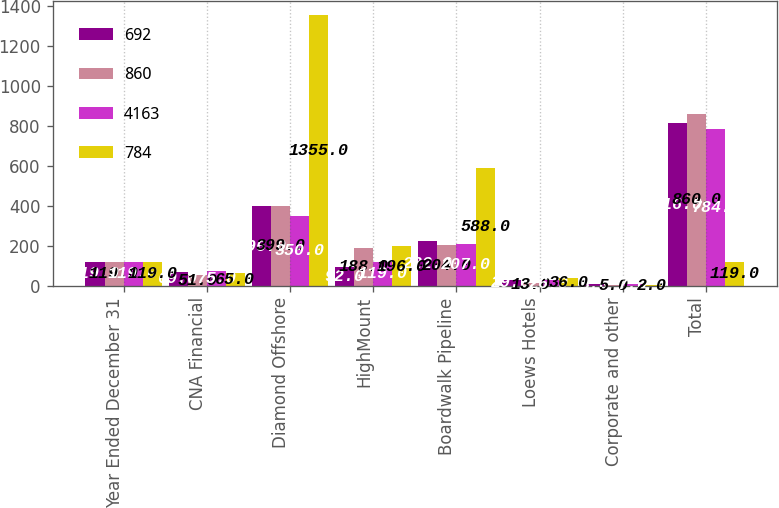Convert chart to OTSL. <chart><loc_0><loc_0><loc_500><loc_500><stacked_bar_chart><ecel><fcel>Year Ended December 31<fcel>CNA Financial<fcel>Diamond Offshore<fcel>HighMount<fcel>Boardwalk Pipeline<fcel>Loews Hotels<fcel>Corporate and other<fcel>Total<nl><fcel>692<fcel>119<fcel>69<fcel>396<fcel>92<fcel>222<fcel>29<fcel>8<fcel>816<nl><fcel>860<fcel>119<fcel>51<fcel>399<fcel>188<fcel>204<fcel>13<fcel>5<fcel>860<nl><fcel>4163<fcel>119<fcel>75<fcel>350<fcel>119<fcel>207<fcel>26<fcel>7<fcel>784<nl><fcel>784<fcel>119<fcel>65<fcel>1355<fcel>196<fcel>588<fcel>36<fcel>2<fcel>119<nl></chart> 